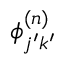<formula> <loc_0><loc_0><loc_500><loc_500>{ \phi } _ { j ^ { \prime } k ^ { \prime } } ^ { ( n ) }</formula> 